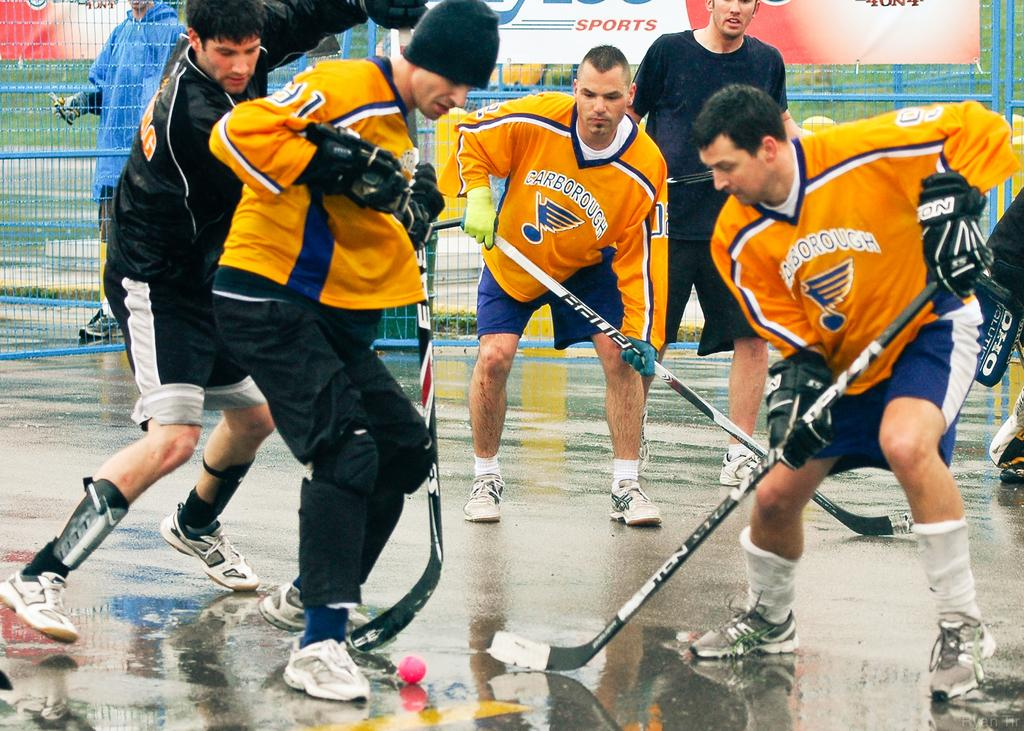<image>
Present a compact description of the photo's key features. The Carborough hockey players scramble for the ball. 